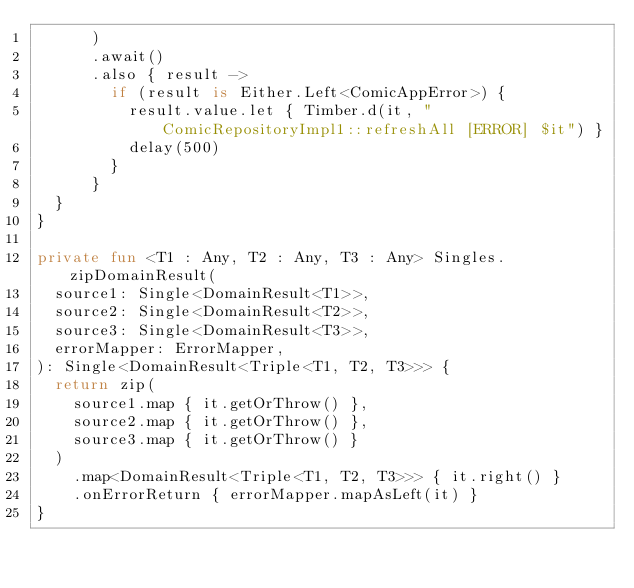Convert code to text. <code><loc_0><loc_0><loc_500><loc_500><_Kotlin_>      )
      .await()
      .also { result ->
        if (result is Either.Left<ComicAppError>) {
          result.value.let { Timber.d(it, "ComicRepositoryImpl1::refreshAll [ERROR] $it") }
          delay(500)
        }
      }
  }
}

private fun <T1 : Any, T2 : Any, T3 : Any> Singles.zipDomainResult(
  source1: Single<DomainResult<T1>>,
  source2: Single<DomainResult<T2>>,
  source3: Single<DomainResult<T3>>,
  errorMapper: ErrorMapper,
): Single<DomainResult<Triple<T1, T2, T3>>> {
  return zip(
    source1.map { it.getOrThrow() },
    source2.map { it.getOrThrow() },
    source3.map { it.getOrThrow() }
  )
    .map<DomainResult<Triple<T1, T2, T3>>> { it.right() }
    .onErrorReturn { errorMapper.mapAsLeft(it) }
}
</code> 